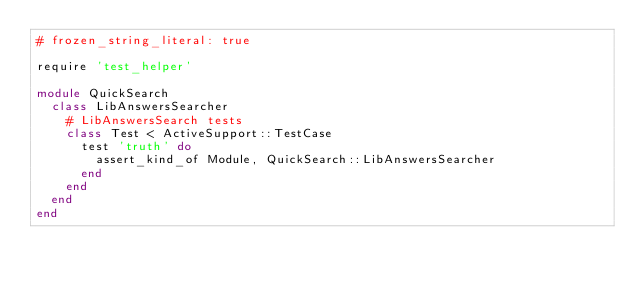Convert code to text. <code><loc_0><loc_0><loc_500><loc_500><_Ruby_># frozen_string_literal: true

require 'test_helper'

module QuickSearch
  class LibAnswersSearcher
    # LibAnswersSearch tests
    class Test < ActiveSupport::TestCase
      test 'truth' do
        assert_kind_of Module, QuickSearch::LibAnswersSearcher
      end
    end
  end
end
</code> 